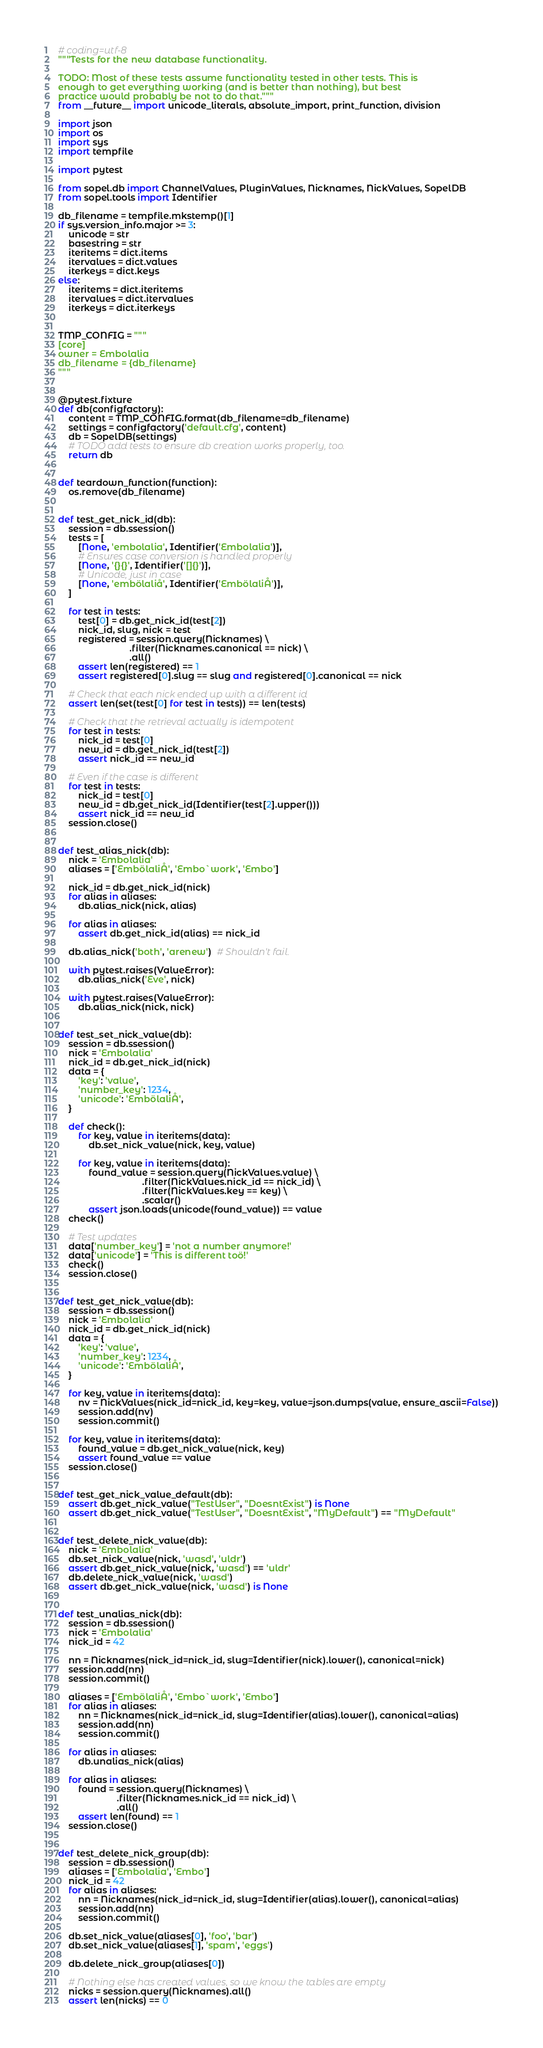Convert code to text. <code><loc_0><loc_0><loc_500><loc_500><_Python_># coding=utf-8
"""Tests for the new database functionality.

TODO: Most of these tests assume functionality tested in other tests. This is
enough to get everything working (and is better than nothing), but best
practice would probably be not to do that."""
from __future__ import unicode_literals, absolute_import, print_function, division

import json
import os
import sys
import tempfile

import pytest

from sopel.db import ChannelValues, PluginValues, Nicknames, NickValues, SopelDB
from sopel.tools import Identifier

db_filename = tempfile.mkstemp()[1]
if sys.version_info.major >= 3:
    unicode = str
    basestring = str
    iteritems = dict.items
    itervalues = dict.values
    iterkeys = dict.keys
else:
    iteritems = dict.iteritems
    itervalues = dict.itervalues
    iterkeys = dict.iterkeys


TMP_CONFIG = """
[core]
owner = Embolalia
db_filename = {db_filename}
"""


@pytest.fixture
def db(configfactory):
    content = TMP_CONFIG.format(db_filename=db_filename)
    settings = configfactory('default.cfg', content)
    db = SopelDB(settings)
    # TODO add tests to ensure db creation works properly, too.
    return db


def teardown_function(function):
    os.remove(db_filename)


def test_get_nick_id(db):
    session = db.ssession()
    tests = [
        [None, 'embolalia', Identifier('Embolalia')],
        # Ensures case conversion is handled properly
        [None, '{}{}', Identifier('[]{}')],
        # Unicode, just in case
        [None, 'embölaliå', Identifier('EmbölaliÅ')],
    ]

    for test in tests:
        test[0] = db.get_nick_id(test[2])
        nick_id, slug, nick = test
        registered = session.query(Nicknames) \
                            .filter(Nicknames.canonical == nick) \
                            .all()
        assert len(registered) == 1
        assert registered[0].slug == slug and registered[0].canonical == nick

    # Check that each nick ended up with a different id
    assert len(set(test[0] for test in tests)) == len(tests)

    # Check that the retrieval actually is idempotent
    for test in tests:
        nick_id = test[0]
        new_id = db.get_nick_id(test[2])
        assert nick_id == new_id

    # Even if the case is different
    for test in tests:
        nick_id = test[0]
        new_id = db.get_nick_id(Identifier(test[2].upper()))
        assert nick_id == new_id
    session.close()


def test_alias_nick(db):
    nick = 'Embolalia'
    aliases = ['EmbölaliÅ', 'Embo`work', 'Embo']

    nick_id = db.get_nick_id(nick)
    for alias in aliases:
        db.alias_nick(nick, alias)

    for alias in aliases:
        assert db.get_nick_id(alias) == nick_id

    db.alias_nick('both', 'arenew')  # Shouldn't fail.

    with pytest.raises(ValueError):
        db.alias_nick('Eve', nick)

    with pytest.raises(ValueError):
        db.alias_nick(nick, nick)


def test_set_nick_value(db):
    session = db.ssession()
    nick = 'Embolalia'
    nick_id = db.get_nick_id(nick)
    data = {
        'key': 'value',
        'number_key': 1234,
        'unicode': 'EmbölaliÅ',
    }

    def check():
        for key, value in iteritems(data):
            db.set_nick_value(nick, key, value)

        for key, value in iteritems(data):
            found_value = session.query(NickValues.value) \
                                 .filter(NickValues.nick_id == nick_id) \
                                 .filter(NickValues.key == key) \
                                 .scalar()
            assert json.loads(unicode(found_value)) == value
    check()

    # Test updates
    data['number_key'] = 'not a number anymore!'
    data['unicode'] = 'This is different toö!'
    check()
    session.close()


def test_get_nick_value(db):
    session = db.ssession()
    nick = 'Embolalia'
    nick_id = db.get_nick_id(nick)
    data = {
        'key': 'value',
        'number_key': 1234,
        'unicode': 'EmbölaliÅ',
    }

    for key, value in iteritems(data):
        nv = NickValues(nick_id=nick_id, key=key, value=json.dumps(value, ensure_ascii=False))
        session.add(nv)
        session.commit()

    for key, value in iteritems(data):
        found_value = db.get_nick_value(nick, key)
        assert found_value == value
    session.close()


def test_get_nick_value_default(db):
    assert db.get_nick_value("TestUser", "DoesntExist") is None
    assert db.get_nick_value("TestUser", "DoesntExist", "MyDefault") == "MyDefault"


def test_delete_nick_value(db):
    nick = 'Embolalia'
    db.set_nick_value(nick, 'wasd', 'uldr')
    assert db.get_nick_value(nick, 'wasd') == 'uldr'
    db.delete_nick_value(nick, 'wasd')
    assert db.get_nick_value(nick, 'wasd') is None


def test_unalias_nick(db):
    session = db.ssession()
    nick = 'Embolalia'
    nick_id = 42

    nn = Nicknames(nick_id=nick_id, slug=Identifier(nick).lower(), canonical=nick)
    session.add(nn)
    session.commit()

    aliases = ['EmbölaliÅ', 'Embo`work', 'Embo']
    for alias in aliases:
        nn = Nicknames(nick_id=nick_id, slug=Identifier(alias).lower(), canonical=alias)
        session.add(nn)
        session.commit()

    for alias in aliases:
        db.unalias_nick(alias)

    for alias in aliases:
        found = session.query(Nicknames) \
                       .filter(Nicknames.nick_id == nick_id) \
                       .all()
        assert len(found) == 1
    session.close()


def test_delete_nick_group(db):
    session = db.ssession()
    aliases = ['Embolalia', 'Embo']
    nick_id = 42
    for alias in aliases:
        nn = Nicknames(nick_id=nick_id, slug=Identifier(alias).lower(), canonical=alias)
        session.add(nn)
        session.commit()

    db.set_nick_value(aliases[0], 'foo', 'bar')
    db.set_nick_value(aliases[1], 'spam', 'eggs')

    db.delete_nick_group(aliases[0])

    # Nothing else has created values, so we know the tables are empty
    nicks = session.query(Nicknames).all()
    assert len(nicks) == 0</code> 